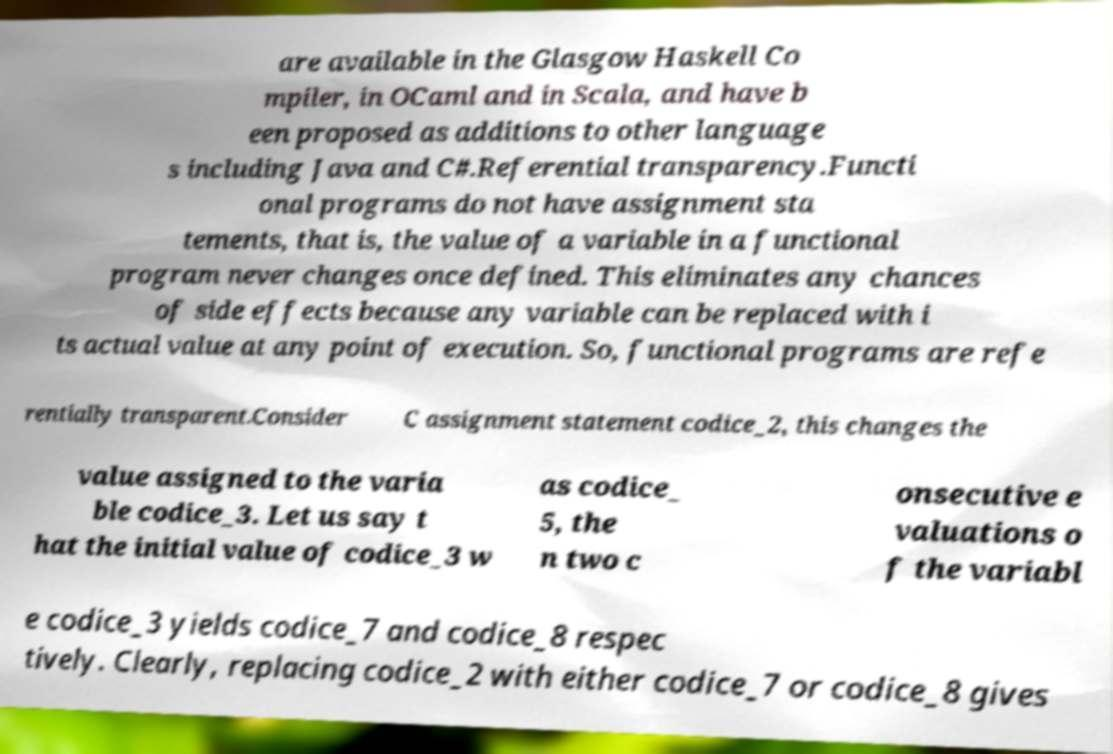I need the written content from this picture converted into text. Can you do that? are available in the Glasgow Haskell Co mpiler, in OCaml and in Scala, and have b een proposed as additions to other language s including Java and C#.Referential transparency.Functi onal programs do not have assignment sta tements, that is, the value of a variable in a functional program never changes once defined. This eliminates any chances of side effects because any variable can be replaced with i ts actual value at any point of execution. So, functional programs are refe rentially transparent.Consider C assignment statement codice_2, this changes the value assigned to the varia ble codice_3. Let us say t hat the initial value of codice_3 w as codice_ 5, the n two c onsecutive e valuations o f the variabl e codice_3 yields codice_7 and codice_8 respec tively. Clearly, replacing codice_2 with either codice_7 or codice_8 gives 